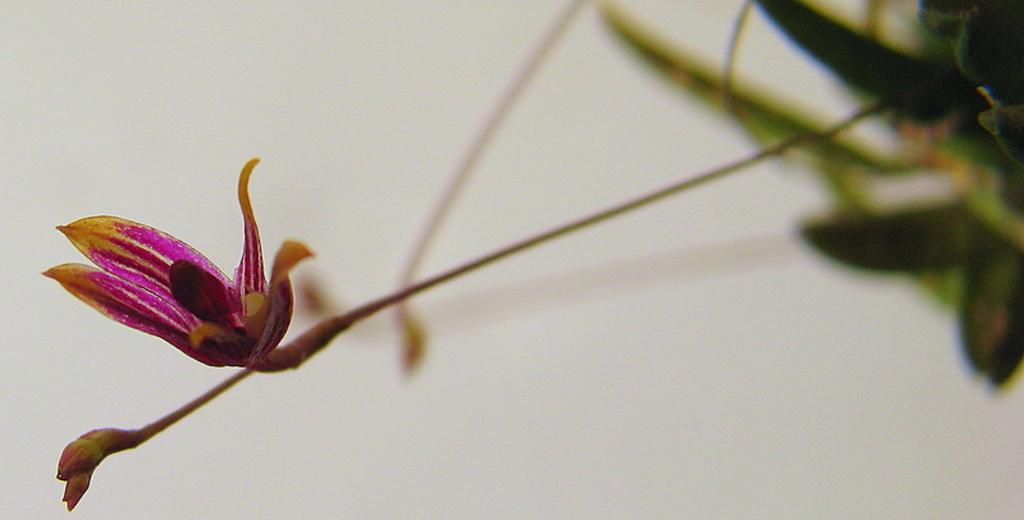What is the main subject of the image? The main subject of the image is a flower. Can you describe any other part of the plant in the image? Yes, there is a bud in the image, which is also part of the plant. What else can be observed about the plant in the image? The plant has leaves. What is the color of the background in the image? The background of the image is white. What type of lipstick is the minister wearing in the image? There is no minister or lipstick present in the image; it features a flower, a bud, and a plant with leaves against a white background. 